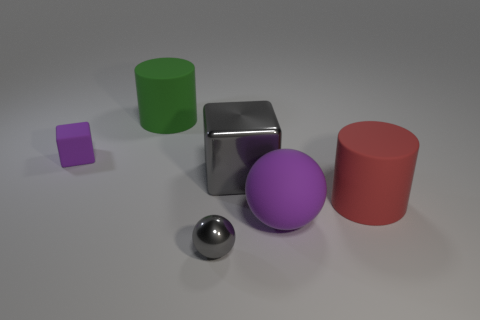What shape is the purple object that is on the right side of the big green matte cylinder?
Give a very brief answer. Sphere. There is a large rubber thing behind the cube that is to the left of the large cylinder that is to the left of the rubber sphere; what is its shape?
Your answer should be very brief. Cylinder. There is a gray metallic thing in front of the large matte sphere; is its shape the same as the purple rubber thing that is in front of the large red matte cylinder?
Make the answer very short. Yes. What number of large rubber cylinders are on the right side of the tiny gray ball and on the left side of the red matte object?
Make the answer very short. 0. What number of other objects are the same size as the purple rubber cube?
Your response must be concise. 1. What is the object that is both behind the gray block and right of the rubber block made of?
Provide a short and direct response. Rubber. Is the color of the small shiny sphere the same as the metallic thing that is behind the shiny ball?
Give a very brief answer. Yes. What size is the red matte thing that is the same shape as the green object?
Make the answer very short. Large. There is a object that is both in front of the gray cube and left of the large purple matte object; what is its shape?
Keep it short and to the point. Sphere. There is a purple block; is its size the same as the sphere to the right of the large shiny thing?
Provide a short and direct response. No. 